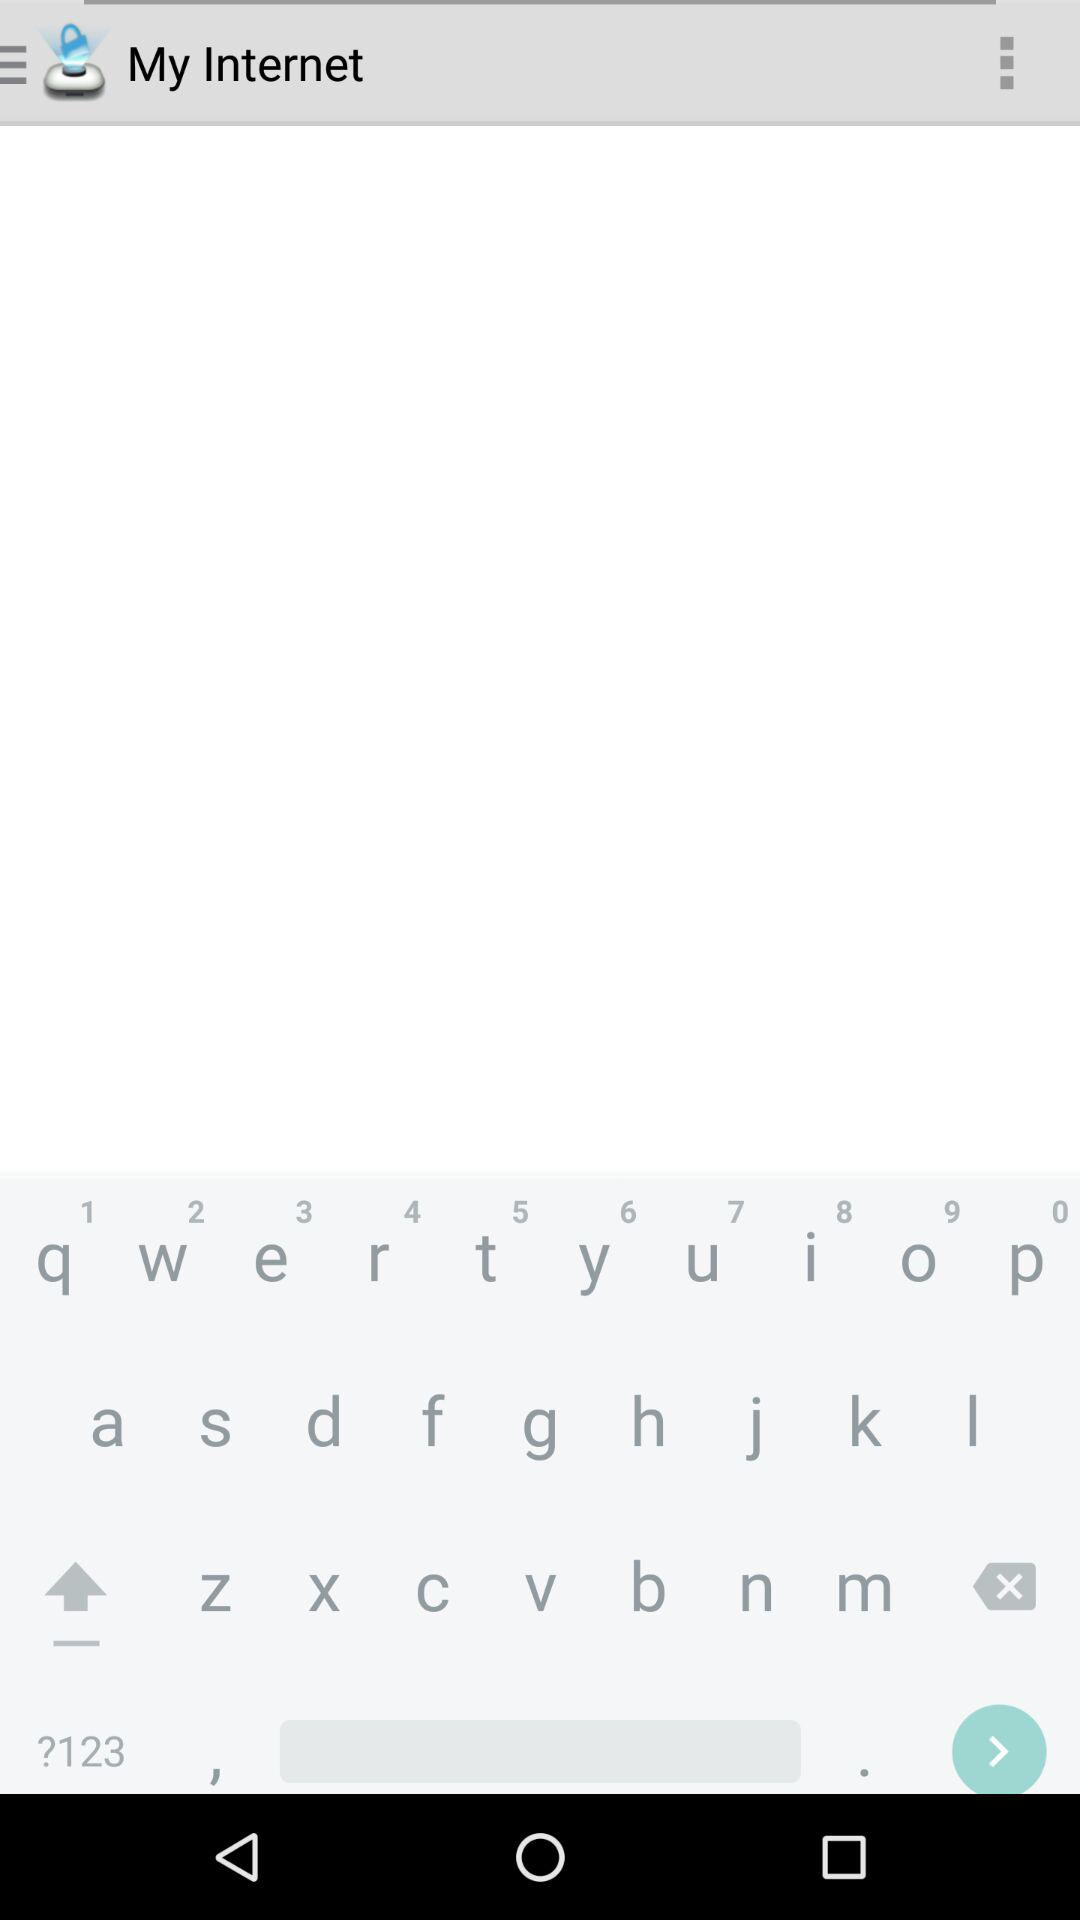What is the application name? The application name is "My Internet". 